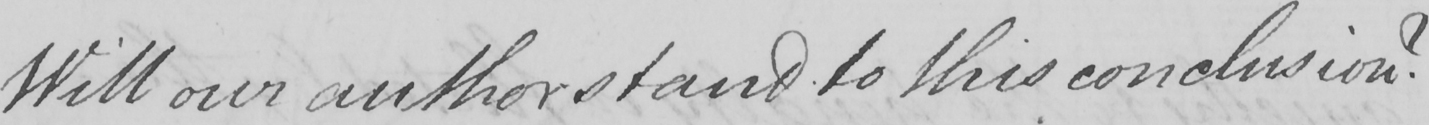What text is written in this handwritten line? Will our author stand to this conclusion ? 